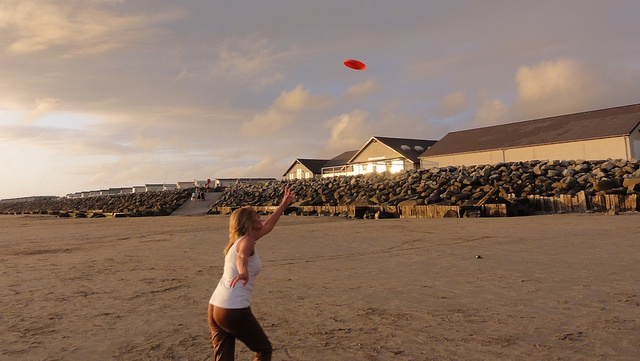Describe the objects in this image and their specific colors. I can see people in tan, black, maroon, gray, and brown tones, frisbee in tan, brown, red, and darkgray tones, people in tan, black, gray, and maroon tones, and people in tan, gray, black, and darkgray tones in this image. 